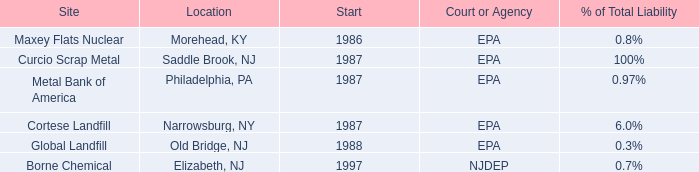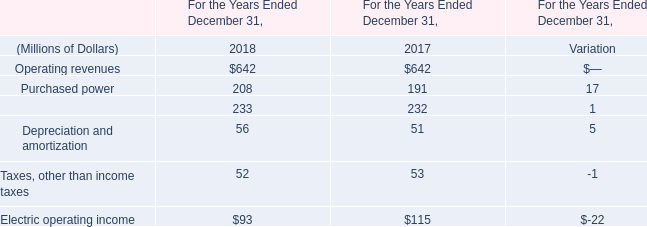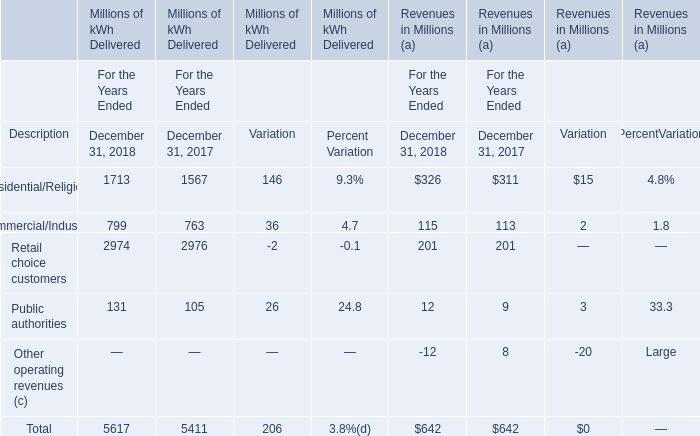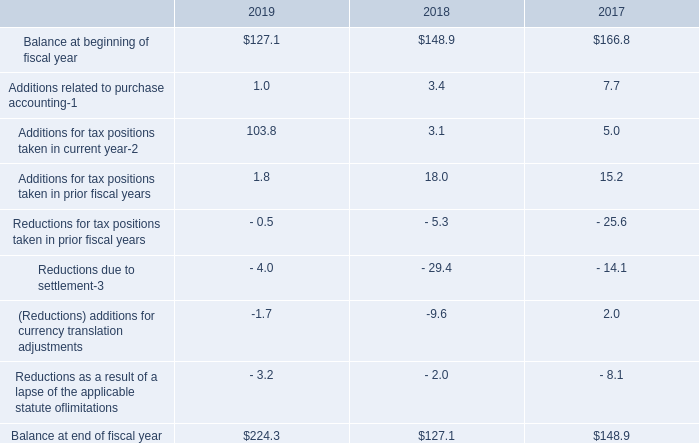What is the difference between the greatest Revenues in Millions (a) in December 31, 2018 and December 31, 2017？ (in million) 
Computations: (326 - 311)
Answer: 15.0. 